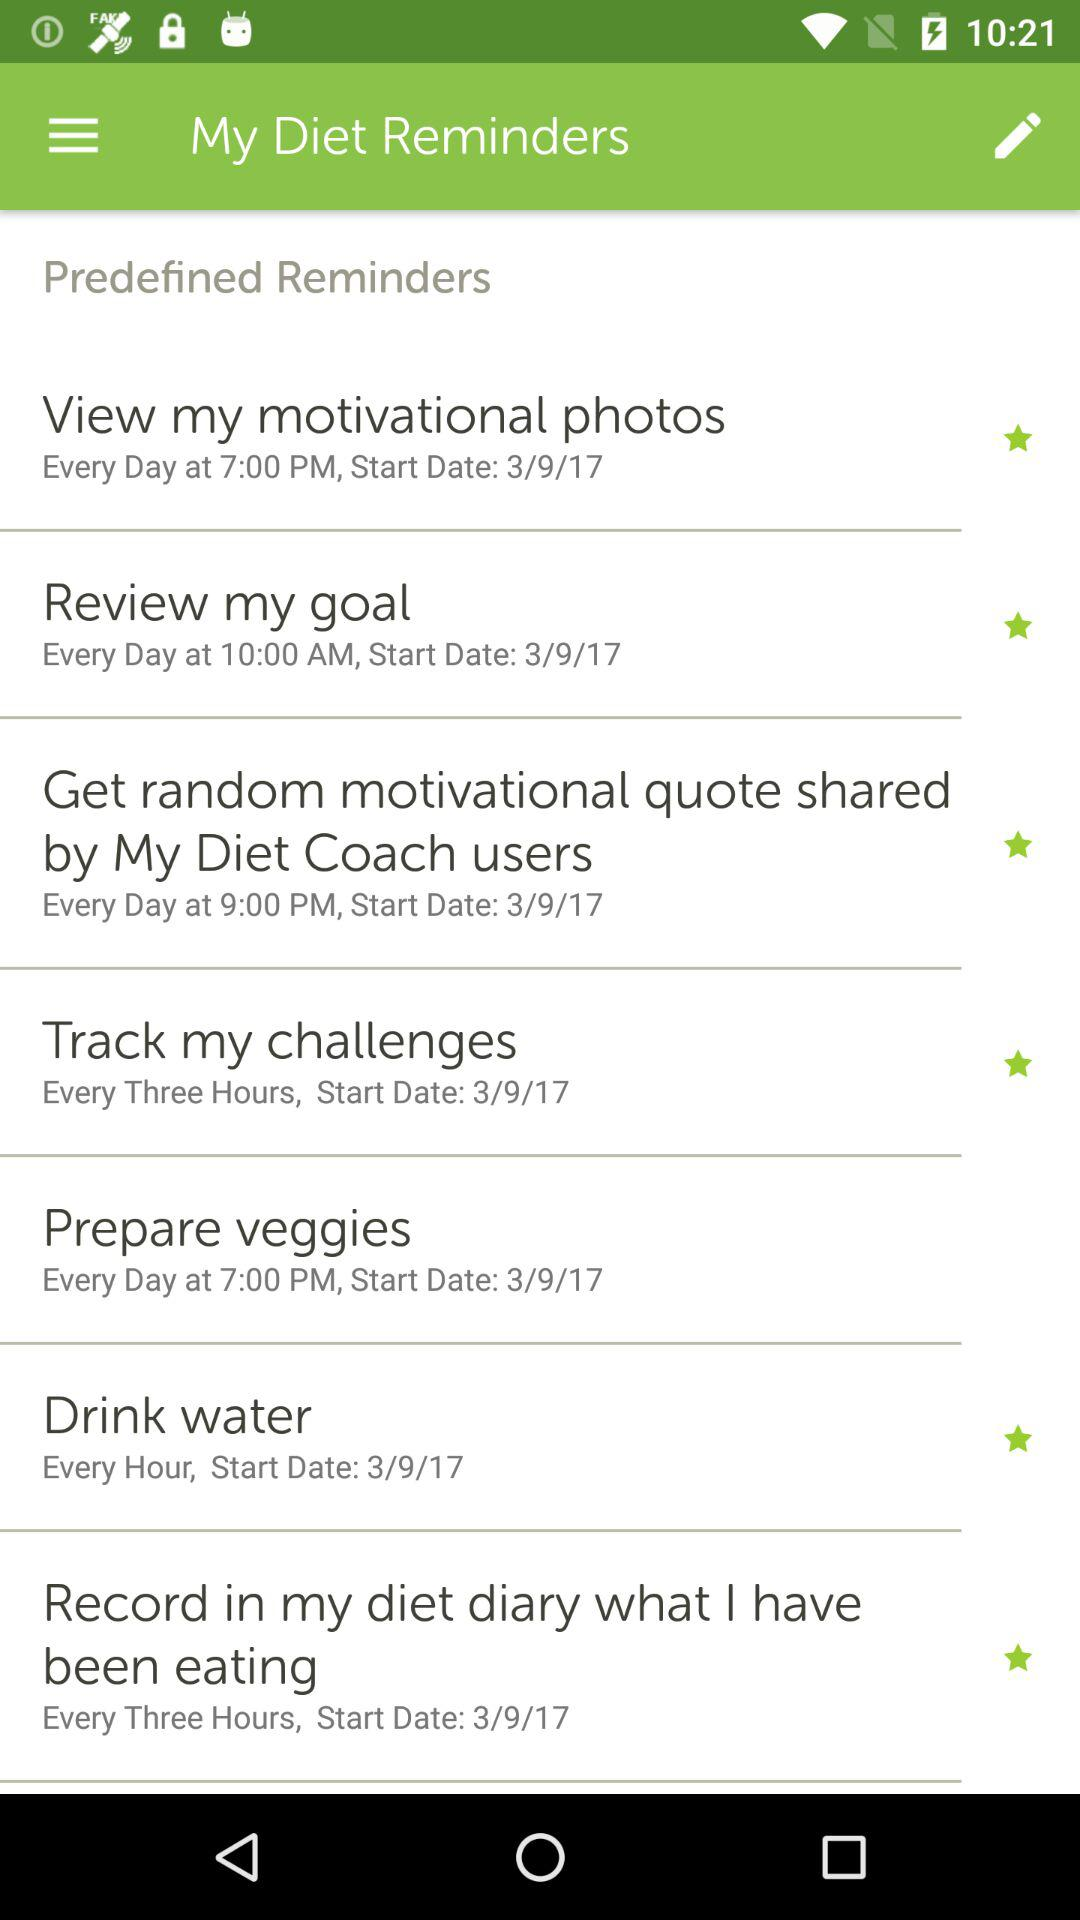What is the time for preparing veggies? The time for preparing veggies is at 7:00 PM. 